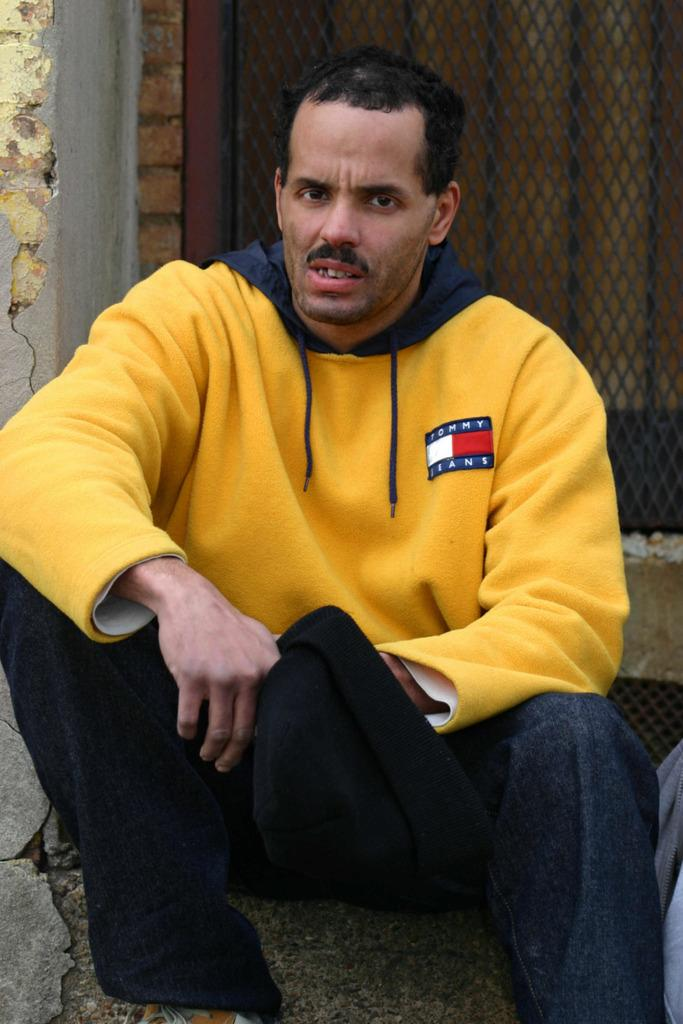<image>
Give a short and clear explanation of the subsequent image. A man wearing a sweatshirt for Tommy Jeans looks at the camera. 